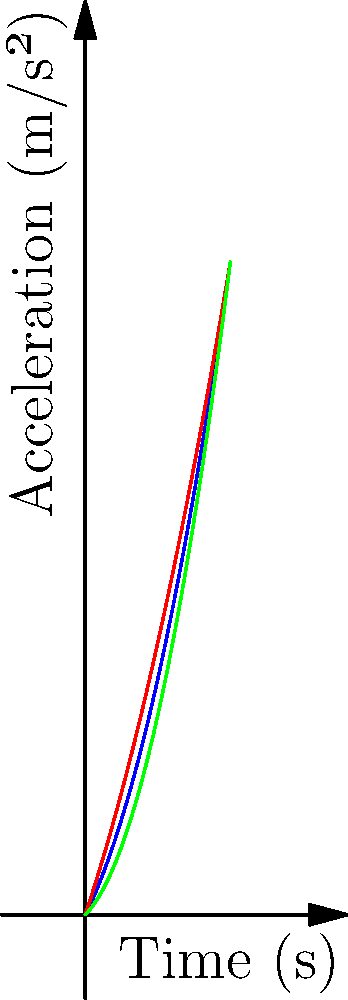You're analyzing the acceleration curves of three race cars in a high-stakes competition. The graph shows the acceleration (in m/s²) of Cars A, B, and C over time (in seconds). Which car would you choose to drive for the most aggressive start in the first 2 seconds of the race, and why? To determine the most aggressive start, we need to analyze the acceleration of each car in the first 2 seconds:

1. Identify the polynomials:
   Car A: $f_1(x) = 0.5x^2 + 2x$
   Car B: $f_2(x) = 0.3x^2 + 3x$
   Car C: $f_3(x) = 0.7x^2 + x$

2. Calculate the acceleration at t = 2s for each car:
   Car A: $f_1(2) = 0.5(2)^2 + 2(2) = 2 + 4 = 6$ m/s²
   Car B: $f_2(2) = 0.3(2)^2 + 3(2) = 1.2 + 6 = 7.2$ m/s²
   Car C: $f_3(2) = 0.7(2)^2 + 2 = 2.8 + 2 = 4.8$ m/s²

3. Compare the accelerations:
   Car B has the highest acceleration at t = 2s.

4. Analyze the curves:
   Car B starts with the steepest slope, indicating the highest initial acceleration.
   Car A has a moderate initial acceleration but increases faster over time.
   Car C starts slow but has the highest rate of increase in acceleration.

5. Consider aggressive driving style:
   For the most aggressive start in the first 2 seconds, Car B is the best choice as it provides the highest initial acceleration and maintains the lead up to the 2-second mark.
Answer: Car B, due to its highest initial acceleration and maintained lead in the first 2 seconds. 